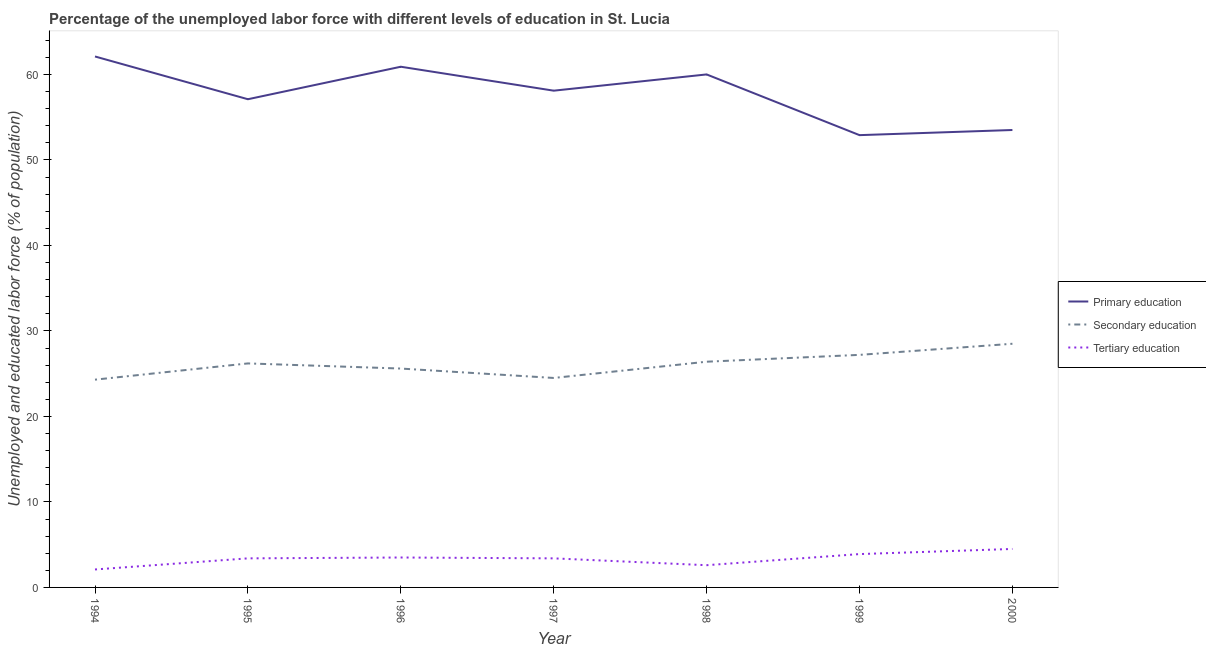How many different coloured lines are there?
Keep it short and to the point. 3. Does the line corresponding to percentage of labor force who received tertiary education intersect with the line corresponding to percentage of labor force who received primary education?
Provide a succinct answer. No. Is the number of lines equal to the number of legend labels?
Ensure brevity in your answer.  Yes. What is the percentage of labor force who received primary education in 1994?
Ensure brevity in your answer.  62.1. Across all years, what is the minimum percentage of labor force who received tertiary education?
Give a very brief answer. 2.1. In which year was the percentage of labor force who received tertiary education minimum?
Give a very brief answer. 1994. What is the total percentage of labor force who received primary education in the graph?
Keep it short and to the point. 404.6. What is the difference between the percentage of labor force who received primary education in 1996 and the percentage of labor force who received secondary education in 2000?
Provide a short and direct response. 32.4. What is the average percentage of labor force who received tertiary education per year?
Make the answer very short. 3.34. In the year 1994, what is the difference between the percentage of labor force who received primary education and percentage of labor force who received secondary education?
Your response must be concise. 37.8. In how many years, is the percentage of labor force who received tertiary education greater than 18 %?
Offer a terse response. 0. What is the ratio of the percentage of labor force who received secondary education in 1997 to that in 1998?
Your response must be concise. 0.93. Is the difference between the percentage of labor force who received primary education in 1998 and 2000 greater than the difference between the percentage of labor force who received tertiary education in 1998 and 2000?
Provide a succinct answer. Yes. What is the difference between the highest and the second highest percentage of labor force who received primary education?
Make the answer very short. 1.2. What is the difference between the highest and the lowest percentage of labor force who received tertiary education?
Give a very brief answer. 2.4. What is the difference between two consecutive major ticks on the Y-axis?
Provide a succinct answer. 10. Does the graph contain any zero values?
Offer a terse response. No. Does the graph contain grids?
Keep it short and to the point. No. Where does the legend appear in the graph?
Give a very brief answer. Center right. How are the legend labels stacked?
Offer a very short reply. Vertical. What is the title of the graph?
Your answer should be very brief. Percentage of the unemployed labor force with different levels of education in St. Lucia. What is the label or title of the Y-axis?
Offer a terse response. Unemployed and educated labor force (% of population). What is the Unemployed and educated labor force (% of population) in Primary education in 1994?
Ensure brevity in your answer.  62.1. What is the Unemployed and educated labor force (% of population) of Secondary education in 1994?
Make the answer very short. 24.3. What is the Unemployed and educated labor force (% of population) of Tertiary education in 1994?
Provide a short and direct response. 2.1. What is the Unemployed and educated labor force (% of population) in Primary education in 1995?
Your response must be concise. 57.1. What is the Unemployed and educated labor force (% of population) in Secondary education in 1995?
Make the answer very short. 26.2. What is the Unemployed and educated labor force (% of population) of Tertiary education in 1995?
Provide a short and direct response. 3.4. What is the Unemployed and educated labor force (% of population) of Primary education in 1996?
Offer a very short reply. 60.9. What is the Unemployed and educated labor force (% of population) of Secondary education in 1996?
Give a very brief answer. 25.6. What is the Unemployed and educated labor force (% of population) of Primary education in 1997?
Offer a terse response. 58.1. What is the Unemployed and educated labor force (% of population) of Tertiary education in 1997?
Provide a succinct answer. 3.4. What is the Unemployed and educated labor force (% of population) in Secondary education in 1998?
Provide a short and direct response. 26.4. What is the Unemployed and educated labor force (% of population) of Tertiary education in 1998?
Your response must be concise. 2.6. What is the Unemployed and educated labor force (% of population) in Primary education in 1999?
Keep it short and to the point. 52.9. What is the Unemployed and educated labor force (% of population) of Secondary education in 1999?
Ensure brevity in your answer.  27.2. What is the Unemployed and educated labor force (% of population) in Tertiary education in 1999?
Provide a succinct answer. 3.9. What is the Unemployed and educated labor force (% of population) in Primary education in 2000?
Your answer should be very brief. 53.5. Across all years, what is the maximum Unemployed and educated labor force (% of population) in Primary education?
Give a very brief answer. 62.1. Across all years, what is the maximum Unemployed and educated labor force (% of population) in Tertiary education?
Your answer should be compact. 4.5. Across all years, what is the minimum Unemployed and educated labor force (% of population) in Primary education?
Give a very brief answer. 52.9. Across all years, what is the minimum Unemployed and educated labor force (% of population) in Secondary education?
Give a very brief answer. 24.3. Across all years, what is the minimum Unemployed and educated labor force (% of population) in Tertiary education?
Ensure brevity in your answer.  2.1. What is the total Unemployed and educated labor force (% of population) of Primary education in the graph?
Provide a succinct answer. 404.6. What is the total Unemployed and educated labor force (% of population) in Secondary education in the graph?
Provide a succinct answer. 182.7. What is the total Unemployed and educated labor force (% of population) of Tertiary education in the graph?
Keep it short and to the point. 23.4. What is the difference between the Unemployed and educated labor force (% of population) in Primary education in 1994 and that in 1995?
Give a very brief answer. 5. What is the difference between the Unemployed and educated labor force (% of population) in Secondary education in 1994 and that in 1995?
Your response must be concise. -1.9. What is the difference between the Unemployed and educated labor force (% of population) in Tertiary education in 1994 and that in 1995?
Your answer should be very brief. -1.3. What is the difference between the Unemployed and educated labor force (% of population) of Primary education in 1994 and that in 1996?
Your response must be concise. 1.2. What is the difference between the Unemployed and educated labor force (% of population) of Secondary education in 1994 and that in 1996?
Keep it short and to the point. -1.3. What is the difference between the Unemployed and educated labor force (% of population) of Primary education in 1994 and that in 1997?
Your response must be concise. 4. What is the difference between the Unemployed and educated labor force (% of population) of Secondary education in 1994 and that in 1997?
Provide a short and direct response. -0.2. What is the difference between the Unemployed and educated labor force (% of population) in Tertiary education in 1994 and that in 1997?
Keep it short and to the point. -1.3. What is the difference between the Unemployed and educated labor force (% of population) in Secondary education in 1994 and that in 1998?
Your answer should be very brief. -2.1. What is the difference between the Unemployed and educated labor force (% of population) of Tertiary education in 1994 and that in 1998?
Provide a succinct answer. -0.5. What is the difference between the Unemployed and educated labor force (% of population) of Tertiary education in 1994 and that in 1999?
Ensure brevity in your answer.  -1.8. What is the difference between the Unemployed and educated labor force (% of population) in Primary education in 1994 and that in 2000?
Your answer should be very brief. 8.6. What is the difference between the Unemployed and educated labor force (% of population) in Secondary education in 1994 and that in 2000?
Ensure brevity in your answer.  -4.2. What is the difference between the Unemployed and educated labor force (% of population) in Tertiary education in 1994 and that in 2000?
Your answer should be compact. -2.4. What is the difference between the Unemployed and educated labor force (% of population) in Secondary education in 1995 and that in 1997?
Give a very brief answer. 1.7. What is the difference between the Unemployed and educated labor force (% of population) of Primary education in 1995 and that in 1998?
Keep it short and to the point. -2.9. What is the difference between the Unemployed and educated labor force (% of population) in Secondary education in 1995 and that in 1998?
Provide a short and direct response. -0.2. What is the difference between the Unemployed and educated labor force (% of population) of Tertiary education in 1995 and that in 1998?
Your answer should be very brief. 0.8. What is the difference between the Unemployed and educated labor force (% of population) of Primary education in 1995 and that in 1999?
Your response must be concise. 4.2. What is the difference between the Unemployed and educated labor force (% of population) of Secondary education in 1995 and that in 1999?
Make the answer very short. -1. What is the difference between the Unemployed and educated labor force (% of population) in Tertiary education in 1995 and that in 1999?
Provide a short and direct response. -0.5. What is the difference between the Unemployed and educated labor force (% of population) in Primary education in 1995 and that in 2000?
Make the answer very short. 3.6. What is the difference between the Unemployed and educated labor force (% of population) in Primary education in 1996 and that in 1997?
Provide a short and direct response. 2.8. What is the difference between the Unemployed and educated labor force (% of population) in Tertiary education in 1996 and that in 1998?
Offer a very short reply. 0.9. What is the difference between the Unemployed and educated labor force (% of population) in Primary education in 1996 and that in 2000?
Give a very brief answer. 7.4. What is the difference between the Unemployed and educated labor force (% of population) of Tertiary education in 1996 and that in 2000?
Provide a succinct answer. -1. What is the difference between the Unemployed and educated labor force (% of population) of Primary education in 1997 and that in 1998?
Your response must be concise. -1.9. What is the difference between the Unemployed and educated labor force (% of population) of Secondary education in 1997 and that in 1998?
Your answer should be compact. -1.9. What is the difference between the Unemployed and educated labor force (% of population) in Primary education in 1997 and that in 1999?
Provide a short and direct response. 5.2. What is the difference between the Unemployed and educated labor force (% of population) of Primary education in 1997 and that in 2000?
Your response must be concise. 4.6. What is the difference between the Unemployed and educated labor force (% of population) in Tertiary education in 1997 and that in 2000?
Your response must be concise. -1.1. What is the difference between the Unemployed and educated labor force (% of population) in Primary education in 1998 and that in 1999?
Your response must be concise. 7.1. What is the difference between the Unemployed and educated labor force (% of population) in Secondary education in 1998 and that in 1999?
Offer a very short reply. -0.8. What is the difference between the Unemployed and educated labor force (% of population) in Tertiary education in 1998 and that in 2000?
Make the answer very short. -1.9. What is the difference between the Unemployed and educated labor force (% of population) of Primary education in 1999 and that in 2000?
Keep it short and to the point. -0.6. What is the difference between the Unemployed and educated labor force (% of population) in Primary education in 1994 and the Unemployed and educated labor force (% of population) in Secondary education in 1995?
Your answer should be very brief. 35.9. What is the difference between the Unemployed and educated labor force (% of population) of Primary education in 1994 and the Unemployed and educated labor force (% of population) of Tertiary education in 1995?
Provide a succinct answer. 58.7. What is the difference between the Unemployed and educated labor force (% of population) in Secondary education in 1994 and the Unemployed and educated labor force (% of population) in Tertiary education in 1995?
Give a very brief answer. 20.9. What is the difference between the Unemployed and educated labor force (% of population) of Primary education in 1994 and the Unemployed and educated labor force (% of population) of Secondary education in 1996?
Your answer should be very brief. 36.5. What is the difference between the Unemployed and educated labor force (% of population) in Primary education in 1994 and the Unemployed and educated labor force (% of population) in Tertiary education in 1996?
Give a very brief answer. 58.6. What is the difference between the Unemployed and educated labor force (% of population) of Secondary education in 1994 and the Unemployed and educated labor force (% of population) of Tertiary education in 1996?
Ensure brevity in your answer.  20.8. What is the difference between the Unemployed and educated labor force (% of population) in Primary education in 1994 and the Unemployed and educated labor force (% of population) in Secondary education in 1997?
Provide a short and direct response. 37.6. What is the difference between the Unemployed and educated labor force (% of population) of Primary education in 1994 and the Unemployed and educated labor force (% of population) of Tertiary education in 1997?
Ensure brevity in your answer.  58.7. What is the difference between the Unemployed and educated labor force (% of population) in Secondary education in 1994 and the Unemployed and educated labor force (% of population) in Tertiary education in 1997?
Keep it short and to the point. 20.9. What is the difference between the Unemployed and educated labor force (% of population) in Primary education in 1994 and the Unemployed and educated labor force (% of population) in Secondary education in 1998?
Provide a short and direct response. 35.7. What is the difference between the Unemployed and educated labor force (% of population) in Primary education in 1994 and the Unemployed and educated labor force (% of population) in Tertiary education in 1998?
Your answer should be compact. 59.5. What is the difference between the Unemployed and educated labor force (% of population) in Secondary education in 1994 and the Unemployed and educated labor force (% of population) in Tertiary education in 1998?
Make the answer very short. 21.7. What is the difference between the Unemployed and educated labor force (% of population) of Primary education in 1994 and the Unemployed and educated labor force (% of population) of Secondary education in 1999?
Your response must be concise. 34.9. What is the difference between the Unemployed and educated labor force (% of population) in Primary education in 1994 and the Unemployed and educated labor force (% of population) in Tertiary education in 1999?
Provide a succinct answer. 58.2. What is the difference between the Unemployed and educated labor force (% of population) in Secondary education in 1994 and the Unemployed and educated labor force (% of population) in Tertiary education in 1999?
Ensure brevity in your answer.  20.4. What is the difference between the Unemployed and educated labor force (% of population) of Primary education in 1994 and the Unemployed and educated labor force (% of population) of Secondary education in 2000?
Your answer should be very brief. 33.6. What is the difference between the Unemployed and educated labor force (% of population) of Primary education in 1994 and the Unemployed and educated labor force (% of population) of Tertiary education in 2000?
Provide a short and direct response. 57.6. What is the difference between the Unemployed and educated labor force (% of population) in Secondary education in 1994 and the Unemployed and educated labor force (% of population) in Tertiary education in 2000?
Make the answer very short. 19.8. What is the difference between the Unemployed and educated labor force (% of population) of Primary education in 1995 and the Unemployed and educated labor force (% of population) of Secondary education in 1996?
Your answer should be very brief. 31.5. What is the difference between the Unemployed and educated labor force (% of population) of Primary education in 1995 and the Unemployed and educated labor force (% of population) of Tertiary education in 1996?
Give a very brief answer. 53.6. What is the difference between the Unemployed and educated labor force (% of population) in Secondary education in 1995 and the Unemployed and educated labor force (% of population) in Tertiary education in 1996?
Offer a very short reply. 22.7. What is the difference between the Unemployed and educated labor force (% of population) in Primary education in 1995 and the Unemployed and educated labor force (% of population) in Secondary education in 1997?
Offer a very short reply. 32.6. What is the difference between the Unemployed and educated labor force (% of population) in Primary education in 1995 and the Unemployed and educated labor force (% of population) in Tertiary education in 1997?
Provide a short and direct response. 53.7. What is the difference between the Unemployed and educated labor force (% of population) in Secondary education in 1995 and the Unemployed and educated labor force (% of population) in Tertiary education in 1997?
Your answer should be very brief. 22.8. What is the difference between the Unemployed and educated labor force (% of population) in Primary education in 1995 and the Unemployed and educated labor force (% of population) in Secondary education in 1998?
Your answer should be compact. 30.7. What is the difference between the Unemployed and educated labor force (% of population) of Primary education in 1995 and the Unemployed and educated labor force (% of population) of Tertiary education in 1998?
Provide a succinct answer. 54.5. What is the difference between the Unemployed and educated labor force (% of population) in Secondary education in 1995 and the Unemployed and educated labor force (% of population) in Tertiary education in 1998?
Give a very brief answer. 23.6. What is the difference between the Unemployed and educated labor force (% of population) of Primary education in 1995 and the Unemployed and educated labor force (% of population) of Secondary education in 1999?
Keep it short and to the point. 29.9. What is the difference between the Unemployed and educated labor force (% of population) in Primary education in 1995 and the Unemployed and educated labor force (% of population) in Tertiary education in 1999?
Keep it short and to the point. 53.2. What is the difference between the Unemployed and educated labor force (% of population) in Secondary education in 1995 and the Unemployed and educated labor force (% of population) in Tertiary education in 1999?
Keep it short and to the point. 22.3. What is the difference between the Unemployed and educated labor force (% of population) in Primary education in 1995 and the Unemployed and educated labor force (% of population) in Secondary education in 2000?
Give a very brief answer. 28.6. What is the difference between the Unemployed and educated labor force (% of population) in Primary education in 1995 and the Unemployed and educated labor force (% of population) in Tertiary education in 2000?
Make the answer very short. 52.6. What is the difference between the Unemployed and educated labor force (% of population) in Secondary education in 1995 and the Unemployed and educated labor force (% of population) in Tertiary education in 2000?
Your answer should be very brief. 21.7. What is the difference between the Unemployed and educated labor force (% of population) in Primary education in 1996 and the Unemployed and educated labor force (% of population) in Secondary education in 1997?
Provide a short and direct response. 36.4. What is the difference between the Unemployed and educated labor force (% of population) in Primary education in 1996 and the Unemployed and educated labor force (% of population) in Tertiary education in 1997?
Provide a succinct answer. 57.5. What is the difference between the Unemployed and educated labor force (% of population) in Secondary education in 1996 and the Unemployed and educated labor force (% of population) in Tertiary education in 1997?
Your answer should be compact. 22.2. What is the difference between the Unemployed and educated labor force (% of population) in Primary education in 1996 and the Unemployed and educated labor force (% of population) in Secondary education in 1998?
Provide a short and direct response. 34.5. What is the difference between the Unemployed and educated labor force (% of population) in Primary education in 1996 and the Unemployed and educated labor force (% of population) in Tertiary education in 1998?
Offer a very short reply. 58.3. What is the difference between the Unemployed and educated labor force (% of population) of Primary education in 1996 and the Unemployed and educated labor force (% of population) of Secondary education in 1999?
Your answer should be compact. 33.7. What is the difference between the Unemployed and educated labor force (% of population) in Primary education in 1996 and the Unemployed and educated labor force (% of population) in Tertiary education in 1999?
Keep it short and to the point. 57. What is the difference between the Unemployed and educated labor force (% of population) in Secondary education in 1996 and the Unemployed and educated labor force (% of population) in Tertiary education in 1999?
Provide a short and direct response. 21.7. What is the difference between the Unemployed and educated labor force (% of population) of Primary education in 1996 and the Unemployed and educated labor force (% of population) of Secondary education in 2000?
Offer a terse response. 32.4. What is the difference between the Unemployed and educated labor force (% of population) of Primary education in 1996 and the Unemployed and educated labor force (% of population) of Tertiary education in 2000?
Make the answer very short. 56.4. What is the difference between the Unemployed and educated labor force (% of population) in Secondary education in 1996 and the Unemployed and educated labor force (% of population) in Tertiary education in 2000?
Keep it short and to the point. 21.1. What is the difference between the Unemployed and educated labor force (% of population) in Primary education in 1997 and the Unemployed and educated labor force (% of population) in Secondary education in 1998?
Offer a terse response. 31.7. What is the difference between the Unemployed and educated labor force (% of population) in Primary education in 1997 and the Unemployed and educated labor force (% of population) in Tertiary education in 1998?
Provide a short and direct response. 55.5. What is the difference between the Unemployed and educated labor force (% of population) of Secondary education in 1997 and the Unemployed and educated labor force (% of population) of Tertiary education in 1998?
Offer a terse response. 21.9. What is the difference between the Unemployed and educated labor force (% of population) in Primary education in 1997 and the Unemployed and educated labor force (% of population) in Secondary education in 1999?
Ensure brevity in your answer.  30.9. What is the difference between the Unemployed and educated labor force (% of population) in Primary education in 1997 and the Unemployed and educated labor force (% of population) in Tertiary education in 1999?
Make the answer very short. 54.2. What is the difference between the Unemployed and educated labor force (% of population) of Secondary education in 1997 and the Unemployed and educated labor force (% of population) of Tertiary education in 1999?
Your response must be concise. 20.6. What is the difference between the Unemployed and educated labor force (% of population) of Primary education in 1997 and the Unemployed and educated labor force (% of population) of Secondary education in 2000?
Your response must be concise. 29.6. What is the difference between the Unemployed and educated labor force (% of population) of Primary education in 1997 and the Unemployed and educated labor force (% of population) of Tertiary education in 2000?
Ensure brevity in your answer.  53.6. What is the difference between the Unemployed and educated labor force (% of population) of Primary education in 1998 and the Unemployed and educated labor force (% of population) of Secondary education in 1999?
Offer a terse response. 32.8. What is the difference between the Unemployed and educated labor force (% of population) in Primary education in 1998 and the Unemployed and educated labor force (% of population) in Tertiary education in 1999?
Give a very brief answer. 56.1. What is the difference between the Unemployed and educated labor force (% of population) in Secondary education in 1998 and the Unemployed and educated labor force (% of population) in Tertiary education in 1999?
Provide a short and direct response. 22.5. What is the difference between the Unemployed and educated labor force (% of population) in Primary education in 1998 and the Unemployed and educated labor force (% of population) in Secondary education in 2000?
Ensure brevity in your answer.  31.5. What is the difference between the Unemployed and educated labor force (% of population) of Primary education in 1998 and the Unemployed and educated labor force (% of population) of Tertiary education in 2000?
Your response must be concise. 55.5. What is the difference between the Unemployed and educated labor force (% of population) in Secondary education in 1998 and the Unemployed and educated labor force (% of population) in Tertiary education in 2000?
Make the answer very short. 21.9. What is the difference between the Unemployed and educated labor force (% of population) in Primary education in 1999 and the Unemployed and educated labor force (% of population) in Secondary education in 2000?
Ensure brevity in your answer.  24.4. What is the difference between the Unemployed and educated labor force (% of population) of Primary education in 1999 and the Unemployed and educated labor force (% of population) of Tertiary education in 2000?
Your response must be concise. 48.4. What is the difference between the Unemployed and educated labor force (% of population) of Secondary education in 1999 and the Unemployed and educated labor force (% of population) of Tertiary education in 2000?
Provide a short and direct response. 22.7. What is the average Unemployed and educated labor force (% of population) in Primary education per year?
Keep it short and to the point. 57.8. What is the average Unemployed and educated labor force (% of population) in Secondary education per year?
Ensure brevity in your answer.  26.1. What is the average Unemployed and educated labor force (% of population) of Tertiary education per year?
Provide a short and direct response. 3.34. In the year 1994, what is the difference between the Unemployed and educated labor force (% of population) of Primary education and Unemployed and educated labor force (% of population) of Secondary education?
Offer a very short reply. 37.8. In the year 1994, what is the difference between the Unemployed and educated labor force (% of population) in Primary education and Unemployed and educated labor force (% of population) in Tertiary education?
Ensure brevity in your answer.  60. In the year 1994, what is the difference between the Unemployed and educated labor force (% of population) in Secondary education and Unemployed and educated labor force (% of population) in Tertiary education?
Make the answer very short. 22.2. In the year 1995, what is the difference between the Unemployed and educated labor force (% of population) of Primary education and Unemployed and educated labor force (% of population) of Secondary education?
Provide a short and direct response. 30.9. In the year 1995, what is the difference between the Unemployed and educated labor force (% of population) in Primary education and Unemployed and educated labor force (% of population) in Tertiary education?
Offer a very short reply. 53.7. In the year 1995, what is the difference between the Unemployed and educated labor force (% of population) of Secondary education and Unemployed and educated labor force (% of population) of Tertiary education?
Offer a terse response. 22.8. In the year 1996, what is the difference between the Unemployed and educated labor force (% of population) of Primary education and Unemployed and educated labor force (% of population) of Secondary education?
Offer a terse response. 35.3. In the year 1996, what is the difference between the Unemployed and educated labor force (% of population) in Primary education and Unemployed and educated labor force (% of population) in Tertiary education?
Provide a succinct answer. 57.4. In the year 1996, what is the difference between the Unemployed and educated labor force (% of population) in Secondary education and Unemployed and educated labor force (% of population) in Tertiary education?
Offer a very short reply. 22.1. In the year 1997, what is the difference between the Unemployed and educated labor force (% of population) of Primary education and Unemployed and educated labor force (% of population) of Secondary education?
Ensure brevity in your answer.  33.6. In the year 1997, what is the difference between the Unemployed and educated labor force (% of population) of Primary education and Unemployed and educated labor force (% of population) of Tertiary education?
Offer a terse response. 54.7. In the year 1997, what is the difference between the Unemployed and educated labor force (% of population) in Secondary education and Unemployed and educated labor force (% of population) in Tertiary education?
Your response must be concise. 21.1. In the year 1998, what is the difference between the Unemployed and educated labor force (% of population) of Primary education and Unemployed and educated labor force (% of population) of Secondary education?
Ensure brevity in your answer.  33.6. In the year 1998, what is the difference between the Unemployed and educated labor force (% of population) of Primary education and Unemployed and educated labor force (% of population) of Tertiary education?
Provide a succinct answer. 57.4. In the year 1998, what is the difference between the Unemployed and educated labor force (% of population) of Secondary education and Unemployed and educated labor force (% of population) of Tertiary education?
Your response must be concise. 23.8. In the year 1999, what is the difference between the Unemployed and educated labor force (% of population) in Primary education and Unemployed and educated labor force (% of population) in Secondary education?
Provide a short and direct response. 25.7. In the year 1999, what is the difference between the Unemployed and educated labor force (% of population) of Primary education and Unemployed and educated labor force (% of population) of Tertiary education?
Make the answer very short. 49. In the year 1999, what is the difference between the Unemployed and educated labor force (% of population) in Secondary education and Unemployed and educated labor force (% of population) in Tertiary education?
Your answer should be compact. 23.3. In the year 2000, what is the difference between the Unemployed and educated labor force (% of population) of Primary education and Unemployed and educated labor force (% of population) of Tertiary education?
Your answer should be compact. 49. In the year 2000, what is the difference between the Unemployed and educated labor force (% of population) in Secondary education and Unemployed and educated labor force (% of population) in Tertiary education?
Offer a terse response. 24. What is the ratio of the Unemployed and educated labor force (% of population) of Primary education in 1994 to that in 1995?
Provide a short and direct response. 1.09. What is the ratio of the Unemployed and educated labor force (% of population) of Secondary education in 1994 to that in 1995?
Provide a succinct answer. 0.93. What is the ratio of the Unemployed and educated labor force (% of population) of Tertiary education in 1994 to that in 1995?
Provide a succinct answer. 0.62. What is the ratio of the Unemployed and educated labor force (% of population) in Primary education in 1994 to that in 1996?
Keep it short and to the point. 1.02. What is the ratio of the Unemployed and educated labor force (% of population) of Secondary education in 1994 to that in 1996?
Provide a short and direct response. 0.95. What is the ratio of the Unemployed and educated labor force (% of population) of Tertiary education in 1994 to that in 1996?
Your response must be concise. 0.6. What is the ratio of the Unemployed and educated labor force (% of population) of Primary education in 1994 to that in 1997?
Ensure brevity in your answer.  1.07. What is the ratio of the Unemployed and educated labor force (% of population) in Secondary education in 1994 to that in 1997?
Provide a short and direct response. 0.99. What is the ratio of the Unemployed and educated labor force (% of population) in Tertiary education in 1994 to that in 1997?
Make the answer very short. 0.62. What is the ratio of the Unemployed and educated labor force (% of population) in Primary education in 1994 to that in 1998?
Provide a short and direct response. 1.03. What is the ratio of the Unemployed and educated labor force (% of population) of Secondary education in 1994 to that in 1998?
Ensure brevity in your answer.  0.92. What is the ratio of the Unemployed and educated labor force (% of population) in Tertiary education in 1994 to that in 1998?
Ensure brevity in your answer.  0.81. What is the ratio of the Unemployed and educated labor force (% of population) in Primary education in 1994 to that in 1999?
Provide a succinct answer. 1.17. What is the ratio of the Unemployed and educated labor force (% of population) in Secondary education in 1994 to that in 1999?
Provide a short and direct response. 0.89. What is the ratio of the Unemployed and educated labor force (% of population) of Tertiary education in 1994 to that in 1999?
Ensure brevity in your answer.  0.54. What is the ratio of the Unemployed and educated labor force (% of population) in Primary education in 1994 to that in 2000?
Keep it short and to the point. 1.16. What is the ratio of the Unemployed and educated labor force (% of population) of Secondary education in 1994 to that in 2000?
Your answer should be compact. 0.85. What is the ratio of the Unemployed and educated labor force (% of population) of Tertiary education in 1994 to that in 2000?
Your response must be concise. 0.47. What is the ratio of the Unemployed and educated labor force (% of population) of Primary education in 1995 to that in 1996?
Offer a very short reply. 0.94. What is the ratio of the Unemployed and educated labor force (% of population) in Secondary education in 1995 to that in 1996?
Provide a succinct answer. 1.02. What is the ratio of the Unemployed and educated labor force (% of population) of Tertiary education in 1995 to that in 1996?
Your answer should be very brief. 0.97. What is the ratio of the Unemployed and educated labor force (% of population) in Primary education in 1995 to that in 1997?
Give a very brief answer. 0.98. What is the ratio of the Unemployed and educated labor force (% of population) of Secondary education in 1995 to that in 1997?
Keep it short and to the point. 1.07. What is the ratio of the Unemployed and educated labor force (% of population) in Tertiary education in 1995 to that in 1997?
Offer a very short reply. 1. What is the ratio of the Unemployed and educated labor force (% of population) of Primary education in 1995 to that in 1998?
Give a very brief answer. 0.95. What is the ratio of the Unemployed and educated labor force (% of population) in Secondary education in 1995 to that in 1998?
Provide a short and direct response. 0.99. What is the ratio of the Unemployed and educated labor force (% of population) in Tertiary education in 1995 to that in 1998?
Make the answer very short. 1.31. What is the ratio of the Unemployed and educated labor force (% of population) in Primary education in 1995 to that in 1999?
Offer a very short reply. 1.08. What is the ratio of the Unemployed and educated labor force (% of population) in Secondary education in 1995 to that in 1999?
Your answer should be very brief. 0.96. What is the ratio of the Unemployed and educated labor force (% of population) in Tertiary education in 1995 to that in 1999?
Give a very brief answer. 0.87. What is the ratio of the Unemployed and educated labor force (% of population) in Primary education in 1995 to that in 2000?
Provide a succinct answer. 1.07. What is the ratio of the Unemployed and educated labor force (% of population) of Secondary education in 1995 to that in 2000?
Your answer should be very brief. 0.92. What is the ratio of the Unemployed and educated labor force (% of population) of Tertiary education in 1995 to that in 2000?
Your answer should be very brief. 0.76. What is the ratio of the Unemployed and educated labor force (% of population) in Primary education in 1996 to that in 1997?
Ensure brevity in your answer.  1.05. What is the ratio of the Unemployed and educated labor force (% of population) of Secondary education in 1996 to that in 1997?
Make the answer very short. 1.04. What is the ratio of the Unemployed and educated labor force (% of population) of Tertiary education in 1996 to that in 1997?
Your answer should be compact. 1.03. What is the ratio of the Unemployed and educated labor force (% of population) in Primary education in 1996 to that in 1998?
Give a very brief answer. 1.01. What is the ratio of the Unemployed and educated labor force (% of population) in Secondary education in 1996 to that in 1998?
Your answer should be very brief. 0.97. What is the ratio of the Unemployed and educated labor force (% of population) in Tertiary education in 1996 to that in 1998?
Offer a terse response. 1.35. What is the ratio of the Unemployed and educated labor force (% of population) in Primary education in 1996 to that in 1999?
Give a very brief answer. 1.15. What is the ratio of the Unemployed and educated labor force (% of population) of Secondary education in 1996 to that in 1999?
Provide a short and direct response. 0.94. What is the ratio of the Unemployed and educated labor force (% of population) in Tertiary education in 1996 to that in 1999?
Make the answer very short. 0.9. What is the ratio of the Unemployed and educated labor force (% of population) of Primary education in 1996 to that in 2000?
Keep it short and to the point. 1.14. What is the ratio of the Unemployed and educated labor force (% of population) of Secondary education in 1996 to that in 2000?
Give a very brief answer. 0.9. What is the ratio of the Unemployed and educated labor force (% of population) in Primary education in 1997 to that in 1998?
Your answer should be very brief. 0.97. What is the ratio of the Unemployed and educated labor force (% of population) in Secondary education in 1997 to that in 1998?
Provide a short and direct response. 0.93. What is the ratio of the Unemployed and educated labor force (% of population) in Tertiary education in 1997 to that in 1998?
Your answer should be compact. 1.31. What is the ratio of the Unemployed and educated labor force (% of population) in Primary education in 1997 to that in 1999?
Provide a succinct answer. 1.1. What is the ratio of the Unemployed and educated labor force (% of population) in Secondary education in 1997 to that in 1999?
Make the answer very short. 0.9. What is the ratio of the Unemployed and educated labor force (% of population) of Tertiary education in 1997 to that in 1999?
Your response must be concise. 0.87. What is the ratio of the Unemployed and educated labor force (% of population) of Primary education in 1997 to that in 2000?
Make the answer very short. 1.09. What is the ratio of the Unemployed and educated labor force (% of population) of Secondary education in 1997 to that in 2000?
Your response must be concise. 0.86. What is the ratio of the Unemployed and educated labor force (% of population) in Tertiary education in 1997 to that in 2000?
Provide a short and direct response. 0.76. What is the ratio of the Unemployed and educated labor force (% of population) in Primary education in 1998 to that in 1999?
Give a very brief answer. 1.13. What is the ratio of the Unemployed and educated labor force (% of population) of Secondary education in 1998 to that in 1999?
Your response must be concise. 0.97. What is the ratio of the Unemployed and educated labor force (% of population) in Tertiary education in 1998 to that in 1999?
Provide a succinct answer. 0.67. What is the ratio of the Unemployed and educated labor force (% of population) of Primary education in 1998 to that in 2000?
Your response must be concise. 1.12. What is the ratio of the Unemployed and educated labor force (% of population) of Secondary education in 1998 to that in 2000?
Offer a very short reply. 0.93. What is the ratio of the Unemployed and educated labor force (% of population) in Tertiary education in 1998 to that in 2000?
Your response must be concise. 0.58. What is the ratio of the Unemployed and educated labor force (% of population) in Primary education in 1999 to that in 2000?
Make the answer very short. 0.99. What is the ratio of the Unemployed and educated labor force (% of population) in Secondary education in 1999 to that in 2000?
Provide a short and direct response. 0.95. What is the ratio of the Unemployed and educated labor force (% of population) of Tertiary education in 1999 to that in 2000?
Your response must be concise. 0.87. What is the difference between the highest and the second highest Unemployed and educated labor force (% of population) in Primary education?
Provide a short and direct response. 1.2. What is the difference between the highest and the second highest Unemployed and educated labor force (% of population) in Secondary education?
Provide a short and direct response. 1.3. What is the difference between the highest and the second highest Unemployed and educated labor force (% of population) of Tertiary education?
Your answer should be very brief. 0.6. 